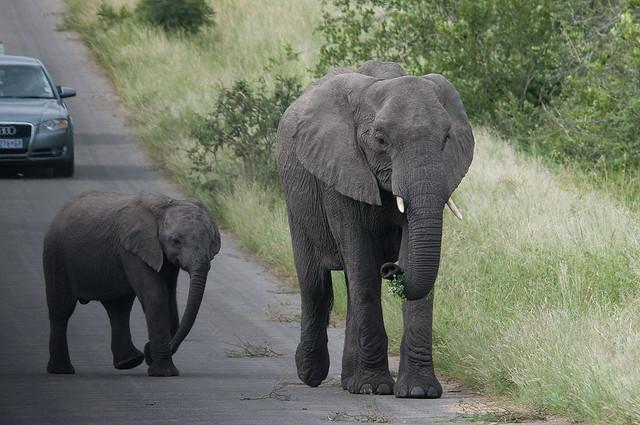What make of car is behind the elephants? audi 